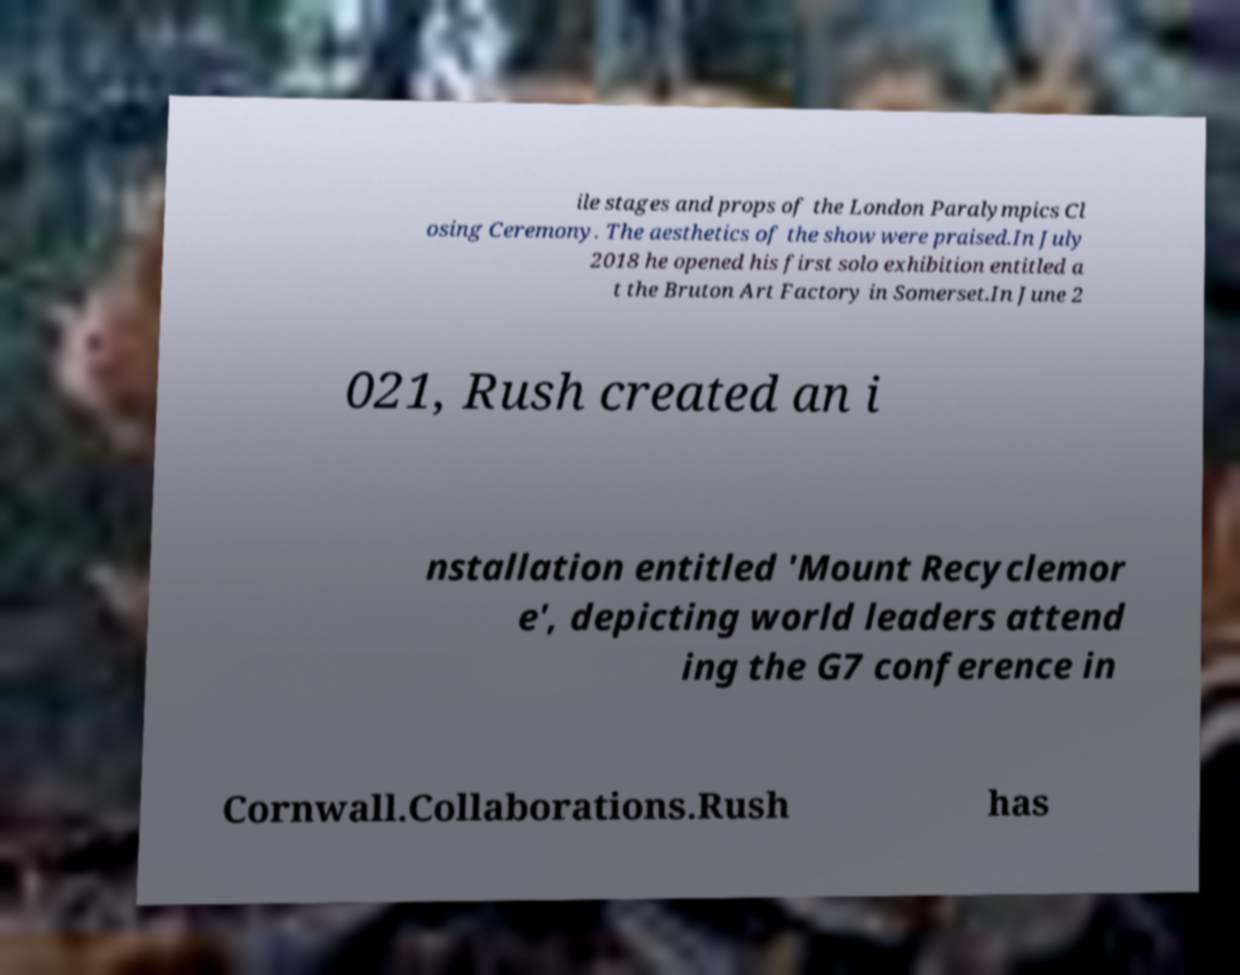Could you assist in decoding the text presented in this image and type it out clearly? ile stages and props of the London Paralympics Cl osing Ceremony. The aesthetics of the show were praised.In July 2018 he opened his first solo exhibition entitled a t the Bruton Art Factory in Somerset.In June 2 021, Rush created an i nstallation entitled 'Mount Recyclemor e', depicting world leaders attend ing the G7 conference in Cornwall.Collaborations.Rush has 